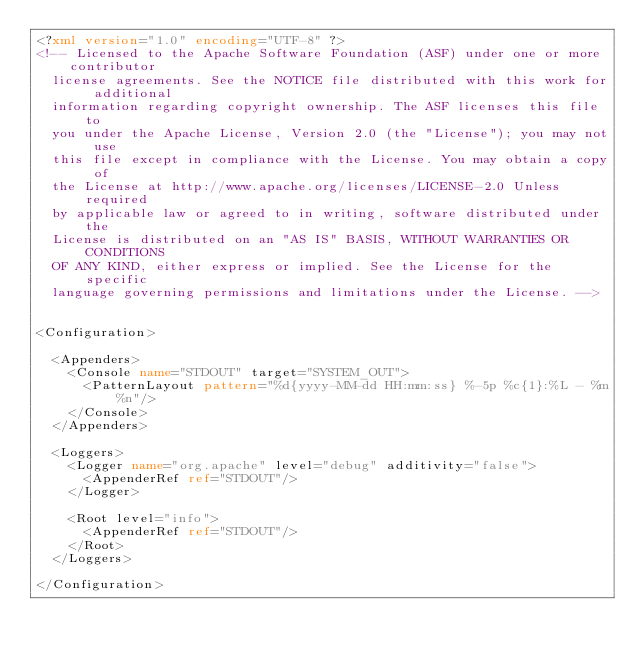<code> <loc_0><loc_0><loc_500><loc_500><_XML_><?xml version="1.0" encoding="UTF-8" ?>
<!-- Licensed to the Apache Software Foundation (ASF) under one or more contributor
  license agreements. See the NOTICE file distributed with this work for additional
  information regarding copyright ownership. The ASF licenses this file to
  you under the Apache License, Version 2.0 (the "License"); you may not use
  this file except in compliance with the License. You may obtain a copy of
  the License at http://www.apache.org/licenses/LICENSE-2.0 Unless required
  by applicable law or agreed to in writing, software distributed under the
  License is distributed on an "AS IS" BASIS, WITHOUT WARRANTIES OR CONDITIONS
  OF ANY KIND, either express or implied. See the License for the specific
  language governing permissions and limitations under the License. -->


<Configuration>

  <Appenders>
    <Console name="STDOUT" target="SYSTEM_OUT">
      <PatternLayout pattern="%d{yyyy-MM-dd HH:mm:ss} %-5p %c{1}:%L - %m%n"/>
    </Console>
  </Appenders>

  <Loggers>
    <Logger name="org.apache" level="debug" additivity="false">
      <AppenderRef ref="STDOUT"/>
    </Logger>

    <Root level="info">
      <AppenderRef ref="STDOUT"/>
    </Root>
  </Loggers>

</Configuration></code> 